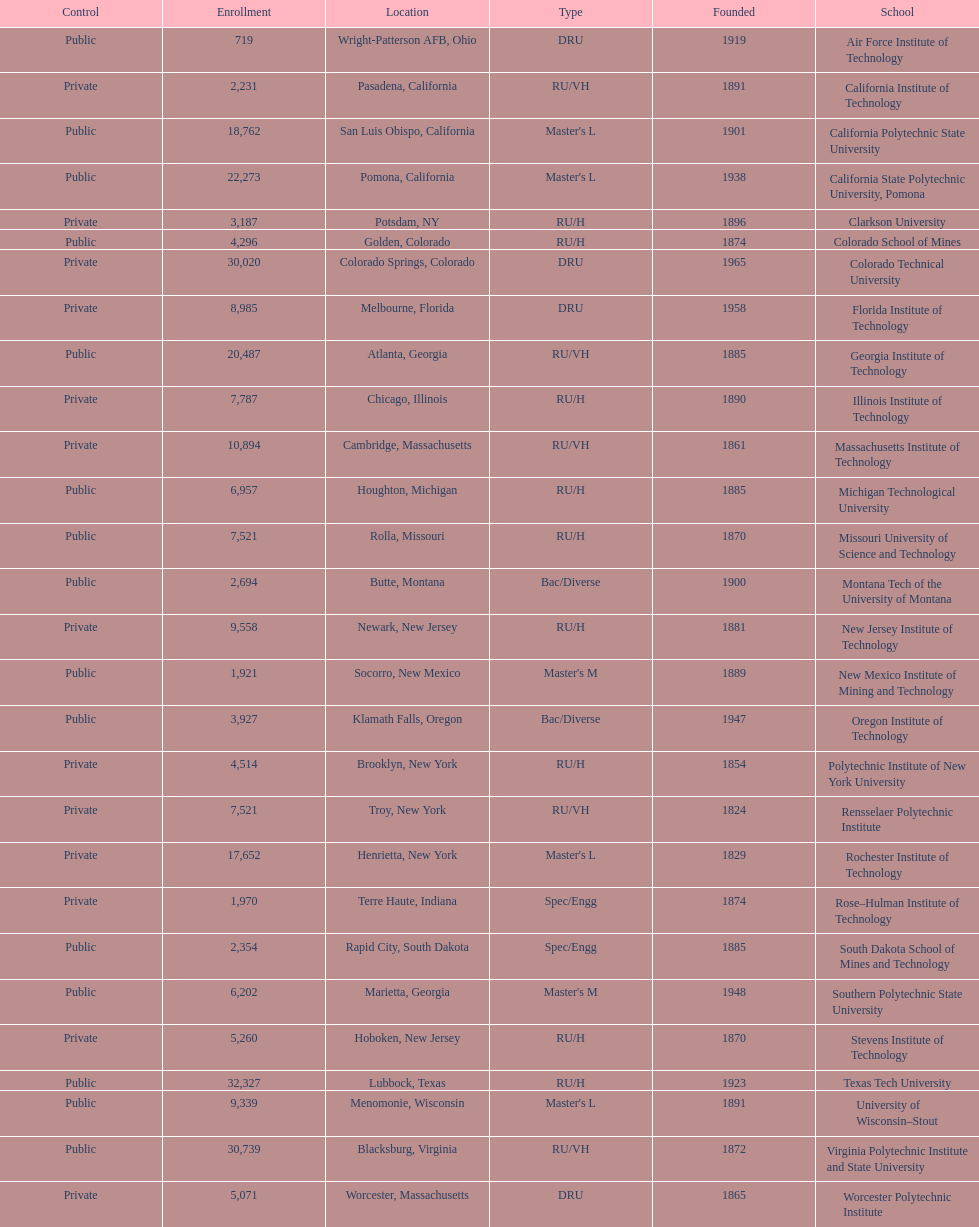What is the difference in enrollment between the top 2 schools listed in the table? 1512. 